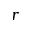Convert formula to latex. <formula><loc_0><loc_0><loc_500><loc_500>r</formula> 